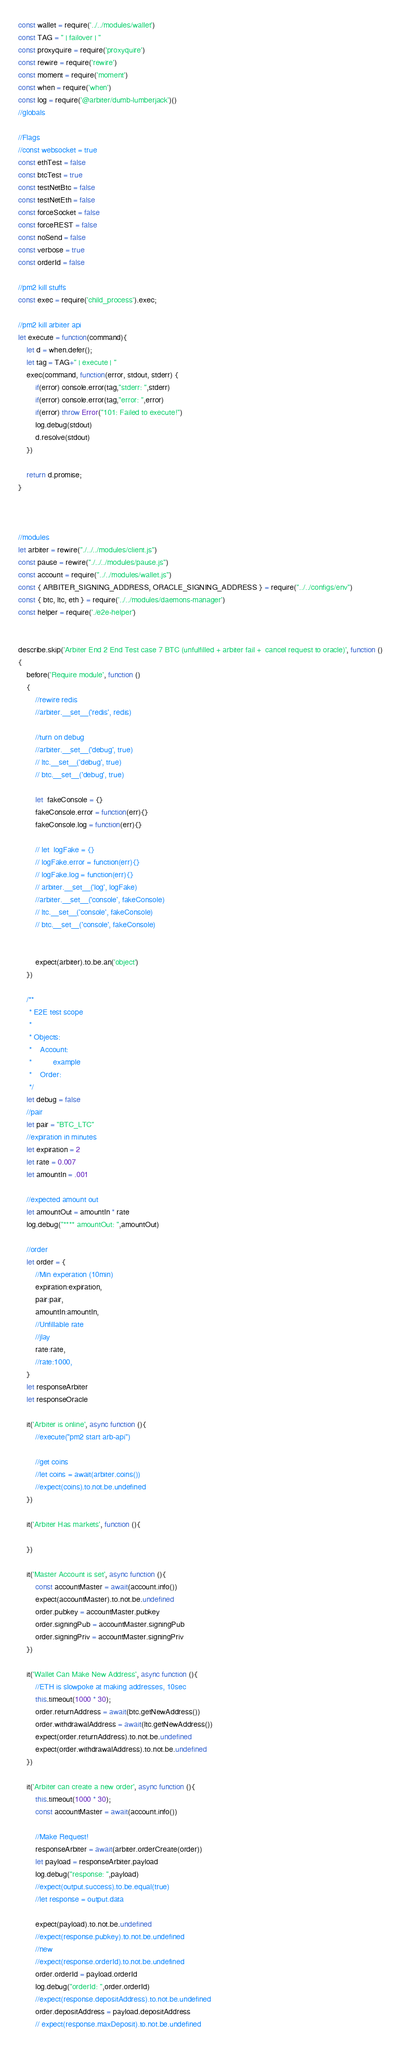Convert code to text. <code><loc_0><loc_0><loc_500><loc_500><_JavaScript_>const wallet = require('../../modules/wallet')
const TAG = " | failover | "
const proxyquire = require('proxyquire')
const rewire = require('rewire')
const moment = require('moment')
const when = require('when')
const log = require('@arbiter/dumb-lumberjack')()
//globals

//Flags
//const websocket = true
const ethTest = false
const btcTest = true
const testNetBtc = false
const testNetEth = false
const forceSocket = false
const forceREST = false
const noSend = false
const verbose = true
const orderId = false

//pm2 kill stuffs
const exec = require('child_process').exec;

//pm2 kill arbiter api
let execute = function(command){
    let d = when.defer();
    let tag = TAG+" | execute | "
    exec(command, function(error, stdout, stderr) {
        if(error) console.error(tag,"stderr: ",stderr)
        if(error) console.error(tag,"error: ",error)
        if(error) throw Error("101: Failed to execute!")
        log.debug(stdout)
        d.resolve(stdout)
    })

    return d.promise;
}



//modules
let arbiter = rewire("./../../modules/client.js")
const pause = rewire("./../../modules/pause.js")
const account = require("../../modules/wallet.js")
const { ARBITER_SIGNING_ADDRESS, ORACLE_SIGNING_ADDRESS } = require("../../configs/env")
const { btc, ltc, eth } = require('../../modules/daemons-manager')
const helper = require('./e2e-helper')


describe.skip('Arbiter End 2 End Test case 7 BTC (unfulfilled + arbiter fail +  cancel request to oracle)', function ()
{
    before('Require module', function ()
    {
        //rewire redis
        //arbiter.__set__('redis', redis)

        //turn on debug
        //arbiter.__set__('debug', true)
        // ltc.__set__('debug', true)
        // btc.__set__('debug', true)

        let  fakeConsole = {}
        fakeConsole.error = function(err){}
        fakeConsole.log = function(err){}

        // let  logFake = {}
        // logFake.error = function(err){}
        // logFake.log = function(err){}
        // arbiter.__set__('log', logFake)
        //arbiter.__set__('console', fakeConsole)
        // ltc.__set__('console', fakeConsole)
        // btc.__set__('console', fakeConsole)


        expect(arbiter).to.be.an('object')
    })

    /**
     * E2E test scope
     *
     * Objects:
     *    Account:
     *          example
     *    Order:
     */
    let debug = false
    //pair
    let pair = "BTC_LTC"
    //expiration in minutes
    let expiration = 2
    let rate = 0.007
    let amountIn = .001

    //expected amount out
    let amountOut = amountIn * rate
    log.debug("**** amountOut: ",amountOut)

    //order
    let order = {
        //Min experation (10min)
        expiration:expiration,
        pair:pair,
        amountIn:amountIn,
        //Unfillable rate
        //jlay
        rate:rate,
        //rate:1000,
    }
    let responseArbiter
    let responseOracle

    it('Arbiter is online', async function (){
        //execute("pm2 start arb-api")

        //get coins
        //let coins = await(arbiter.coins())
        //expect(coins).to.not.be.undefined
    })

    it('Arbiter Has markets', function (){

    })

    it('Master Account is set', async function (){
        const accountMaster = await(account.info())
        expect(accountMaster).to.not.be.undefined
        order.pubkey = accountMaster.pubkey
        order.signingPub = accountMaster.signingPub
        order.signingPriv = accountMaster.signingPriv
    })

    it('Wallet Can Make New Address', async function (){
        //ETH is slowpoke at making addresses, 10sec
        this.timeout(1000 * 30);
        order.returnAddress = await(btc.getNewAddress())
        order.withdrawalAddress = await(ltc.getNewAddress())
        expect(order.returnAddress).to.not.be.undefined
        expect(order.withdrawalAddress).to.not.be.undefined
    })

    it('Arbiter can create a new order', async function (){
        this.timeout(1000 * 30);
        const accountMaster = await(account.info())

        //Make Request!
        responseArbiter = await(arbiter.orderCreate(order))
        let payload = responseArbiter.payload
        log.debug("response: ",payload)
        //expect(output.success).to.be.equal(true)
        //let response = output.data

        expect(payload).to.not.be.undefined
        //expect(response.pubkey).to.not.be.undefined
        //new
        //expect(response.orderId).to.not.be.undefined
        order.orderId = payload.orderId
        log.debug("orderId: ",order.orderId)
        //expect(response.depositAddress).to.not.be.undefined
        order.depositAddress = payload.depositAddress
        // expect(response.maxDeposit).to.not.be.undefined</code> 